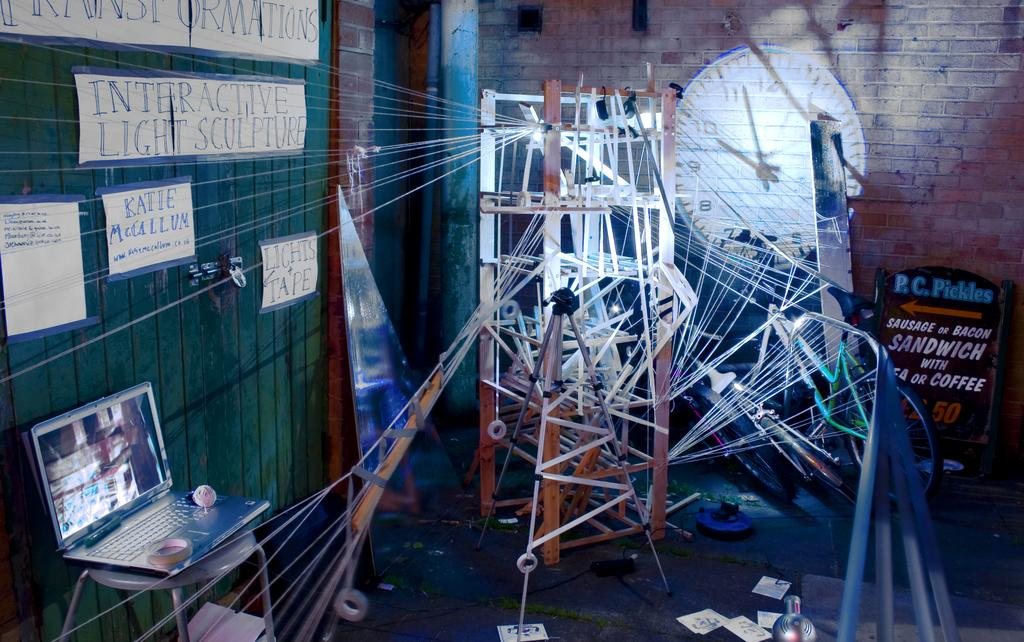Provide a one-sentence caption for the provided image. Sign that says P.C. Pickles in blue under a painting of a clock. 